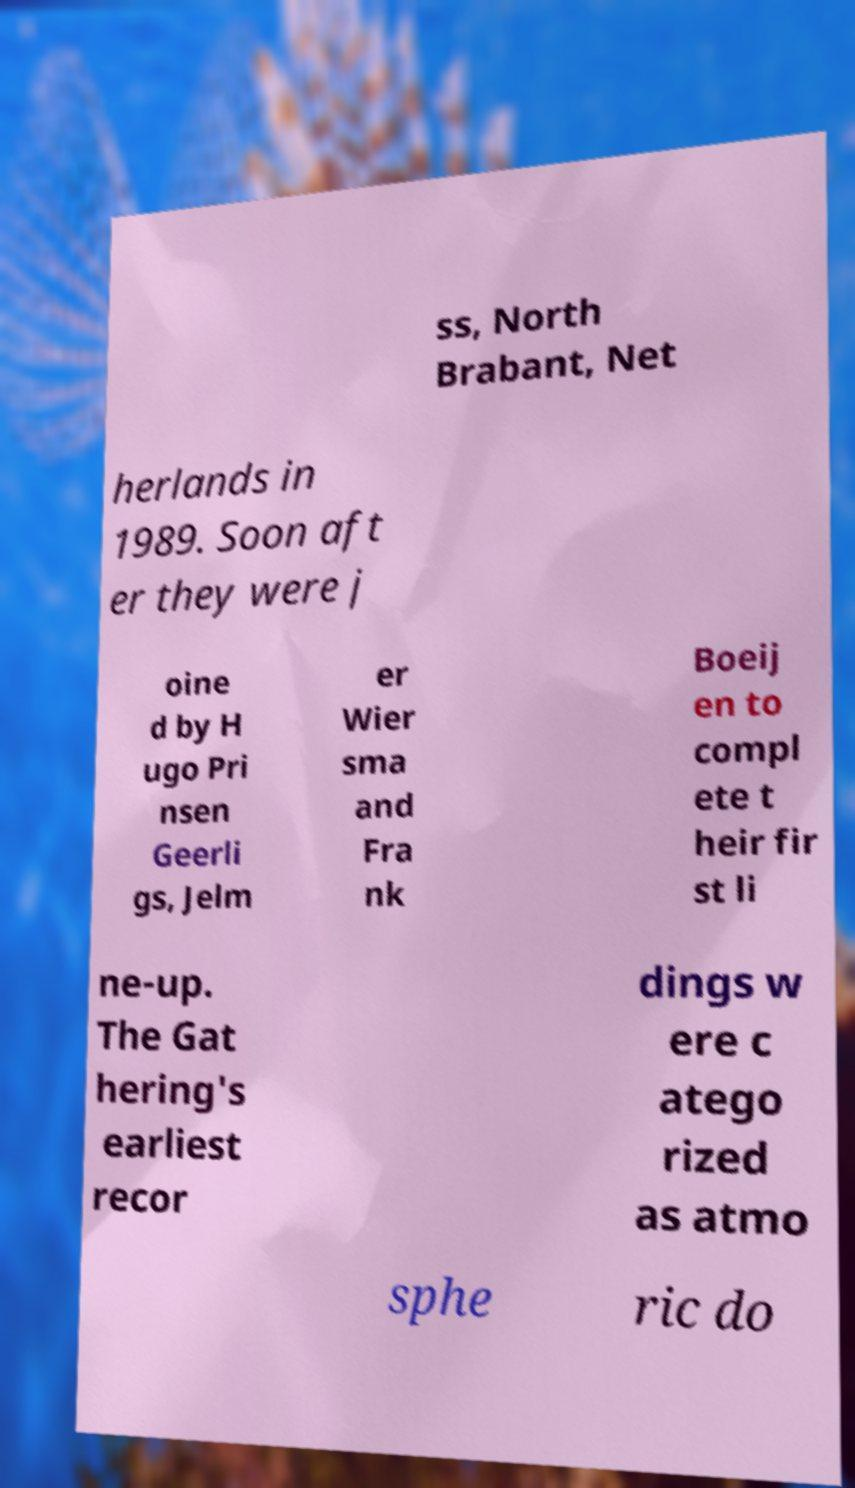Could you assist in decoding the text presented in this image and type it out clearly? ss, North Brabant, Net herlands in 1989. Soon aft er they were j oine d by H ugo Pri nsen Geerli gs, Jelm er Wier sma and Fra nk Boeij en to compl ete t heir fir st li ne-up. The Gat hering's earliest recor dings w ere c atego rized as atmo sphe ric do 